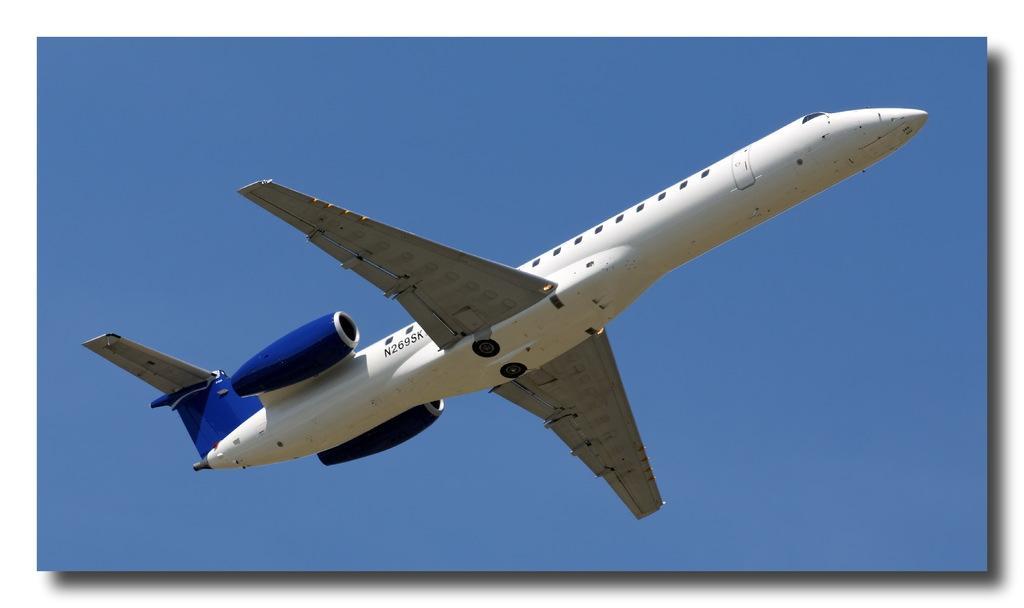Can you describe this image briefly? In the center of the image there is a aeroplane. In the background of the image there is sky. 